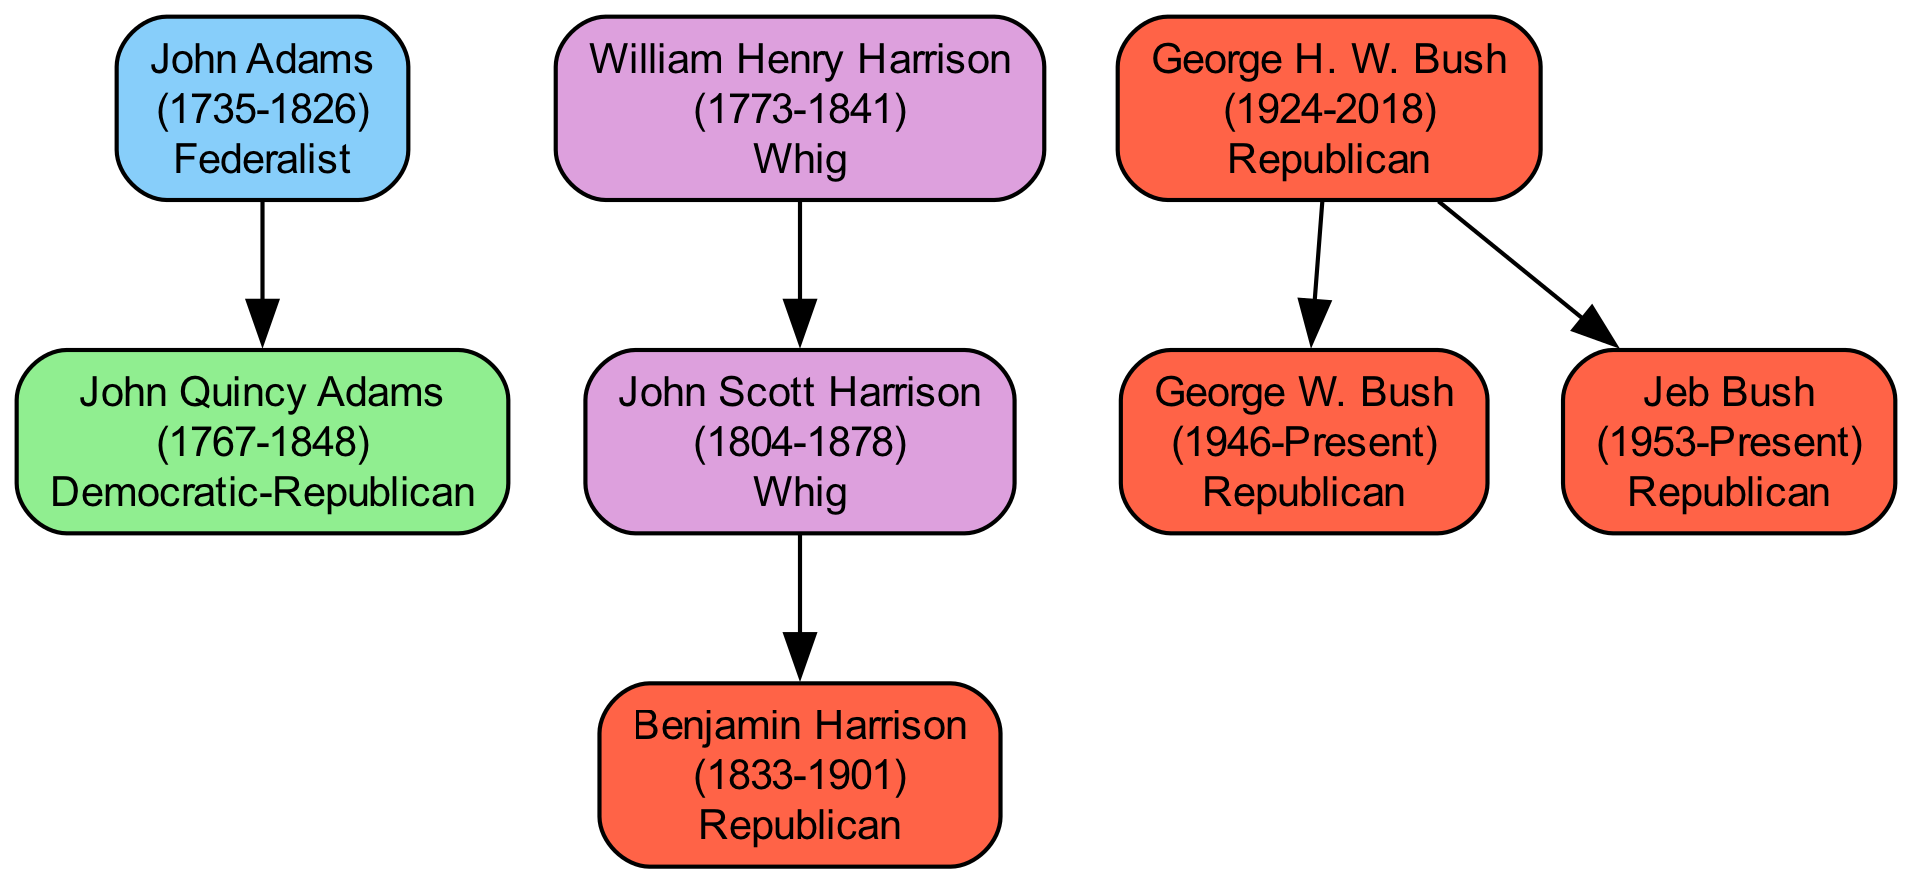What is the political affiliation of John Quincy Adams? John Quincy Adams is listed under John Adams, who is a Federalist. However, John Quincy Adams has his own political affiliation, which is Democratic-Republican.
Answer: Democratic-Republican How many children did George H. W. Bush have? Upon checking the diagram, George H. W. Bush has two children listed: George W. Bush and Jeb Bush.
Answer: 2 What year was Benjamin Harrison born? Benjamin Harrison is found under the lineage of John Scott Harrison, and his birth year is explicitly mentioned as 1833.
Answer: 1833 Which president's child is noted as a Republican? Benjamin Harrison is the child of John Scott Harrison, who belongs to the Whig party, whereas Benjamin himself is a Republican.
Answer: Benjamin Harrison Who is the direct descendant of William Henry Harrison shown in the diagram? According to the lineage in the diagram, John Scott Harrison is the direct child of William Henry Harrison and also a parent to Benjamin Harrison.
Answer: John Scott Harrison What is the color representing the Republican political affiliation? The political affiliation Republican is represented in the diagram with the color corresponding to the color scheme provided, which is a shade of red that is labeled in the diagram.
Answer: Red How many presidents listed are affiliated with the Whig party? The diagram shows William Henry Harrison as a Whig and his child John Scott Harrison is also noted with the same affiliation, thus giving us a total of two individuals listed as Whigs.
Answer: 2 Which commander-in-chief was born in the year 1735? The diagram highlights John Adams, whose birth year is explicitly noted as 1735, making him the individual in question.
Answer: John Adams 